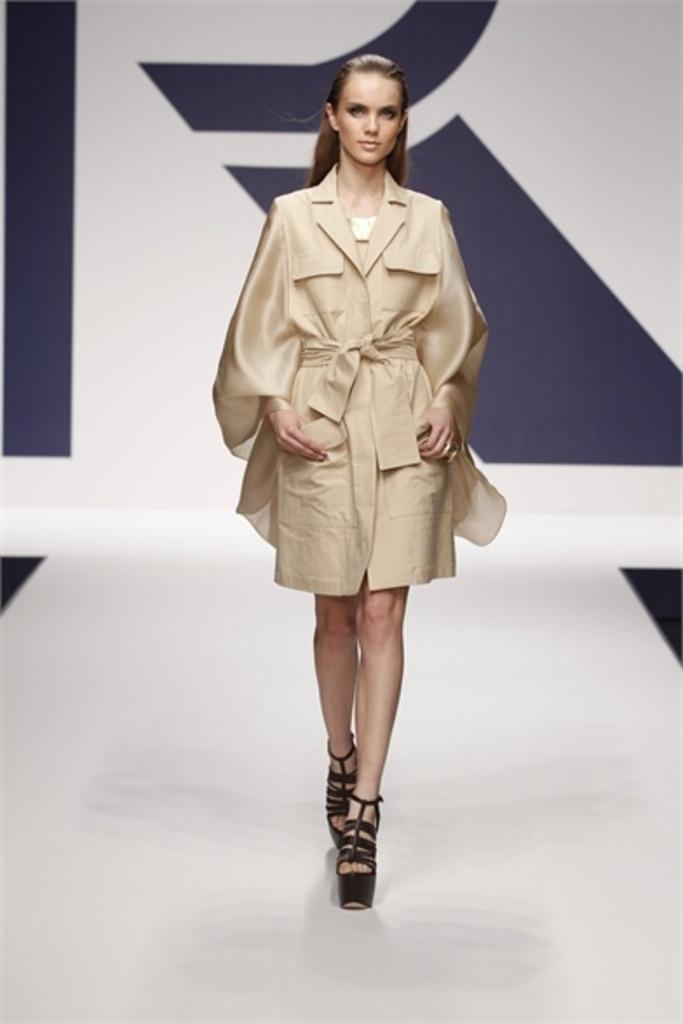Who is present in the image? There is a woman in the image. What is the woman doing in the image? The woman is walking. What type of hammer is the woman holding in the image? There is no hammer present in the image; the woman is simply walking. What kind of soda is the woman drinking while walking in the image? There is no soda present in the image; the woman is just walking. 